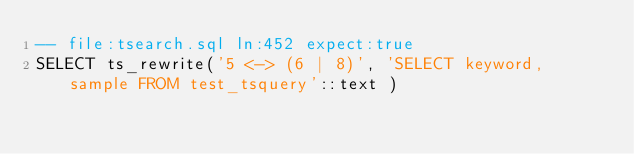<code> <loc_0><loc_0><loc_500><loc_500><_SQL_>-- file:tsearch.sql ln:452 expect:true
SELECT ts_rewrite('5 <-> (6 | 8)', 'SELECT keyword, sample FROM test_tsquery'::text )
</code> 